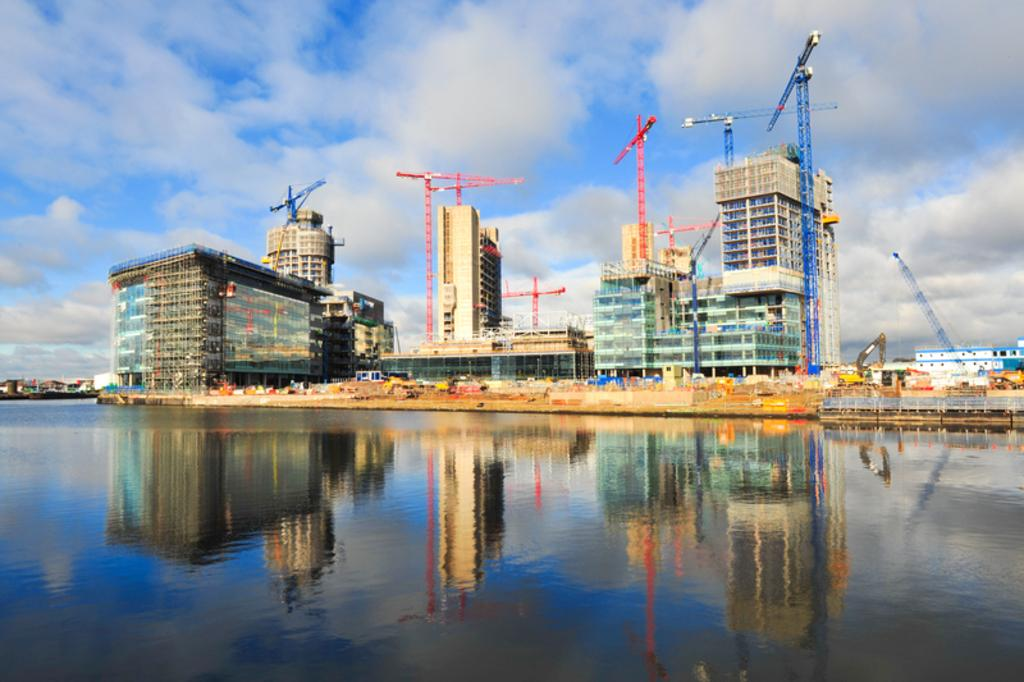What type of buildings can be seen in the image? There are industrial buildings in the image. What can be found inside the industrial buildings? Machines are present in the industrial buildings. What structures are located near the river? There are towers alongside the river. What natural feature is visible in the image? The river is visible in the image. What is the color of the sky in the image? The sky is blue in the image. How many snakes are slithering on the machines in the image? There are no snakes present in the image; it features industrial buildings and machines. What is the wealth status of the people living near the river in the image? There is no information about the wealth status of the people living near the river in the image. 